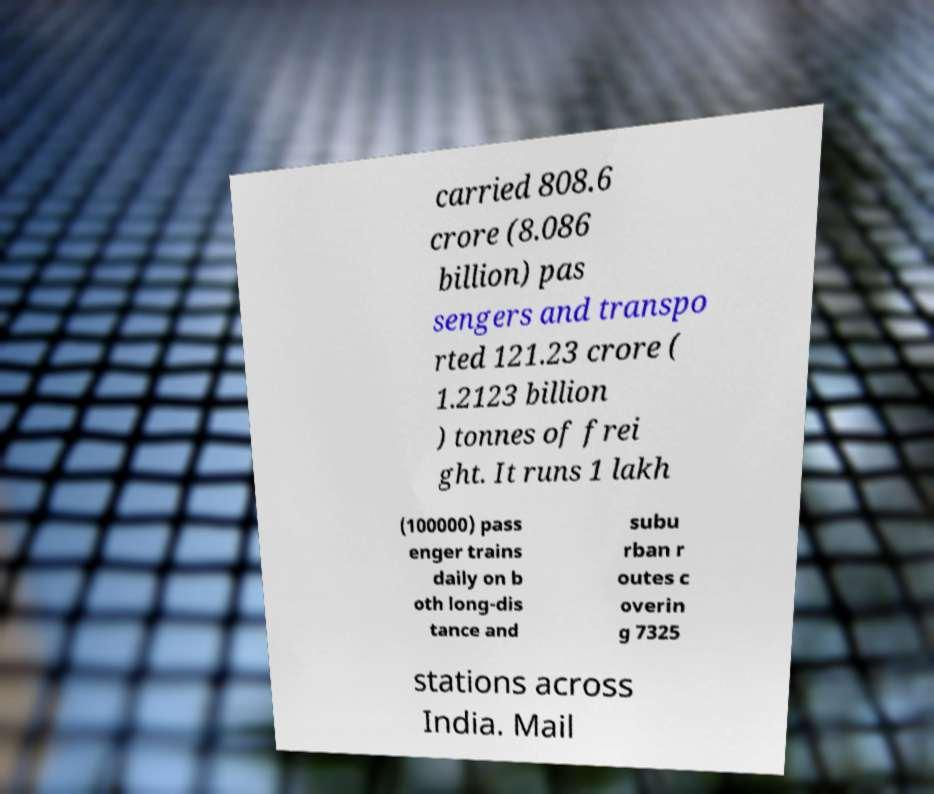Could you extract and type out the text from this image? carried 808.6 crore (8.086 billion) pas sengers and transpo rted 121.23 crore ( 1.2123 billion ) tonnes of frei ght. It runs 1 lakh (100000) pass enger trains daily on b oth long-dis tance and subu rban r outes c overin g 7325 stations across India. Mail 